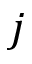<formula> <loc_0><loc_0><loc_500><loc_500>j</formula> 